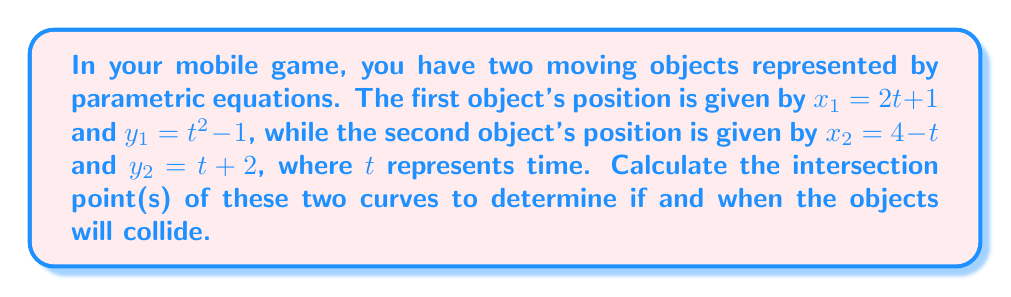Could you help me with this problem? To find the intersection points, we need to solve the system of equations:

$$\begin{cases}
2t + 1 = 4 - t \\
t^2 - 1 = t + 2
\end{cases}$$

Step 1: Solve the first equation for $t$
$2t + 1 = 4 - t$
$3t = 3$
$t = 1$

Step 2: Substitute $t = 1$ into the second equation to verify
$1^2 - 1 = 1 + 2$
$0 = 3$

This is not true, so $t = 1$ is not a solution.

Step 3: Solve the second equation
$t^2 - 1 = t + 2$
$t^2 - t - 3 = 0$

Using the quadratic formula: $t = \frac{-b \pm \sqrt{b^2 - 4ac}}{2a}$

$t = \frac{1 \pm \sqrt{1^2 - 4(1)(-3)}}{2(1)} = \frac{1 \pm \sqrt{13}}{2}$

Step 4: Check these solutions in the first equation
For $t = \frac{1 + \sqrt{13}}{2}$:
$2(\frac{1 + \sqrt{13}}{2}) + 1 = 4 - \frac{1 + \sqrt{13}}{2}$
$1 + \sqrt{13} + 1 = 4 - \frac{1 + \sqrt{13}}{2}$
$2 + \sqrt{13} = \frac{7 - \sqrt{13}}{2}$
$4 + 2\sqrt{13} = 7 - \sqrt{13}$
$3\sqrt{13} = 3$
$\sqrt{13} = 1$ (which is false)

For $t = \frac{1 - \sqrt{13}}{2}$:
$2(\frac{1 - \sqrt{13}}{2}) + 1 = 4 - \frac{1 - \sqrt{13}}{2}$
$1 - \sqrt{13} + 1 = 4 - \frac{1 - \sqrt{13}}{2}$
$2 - \sqrt{13} = \frac{7 + \sqrt{13}}{2}$
$4 - 2\sqrt{13} = 7 + \sqrt{13}$
$-3\sqrt{13} = 3$
$\sqrt{13} = -1$ (which is false)

Therefore, there are no real solutions, meaning the curves do not intersect.
Answer: The two parametric curves do not intersect, so the objects will not collide. 